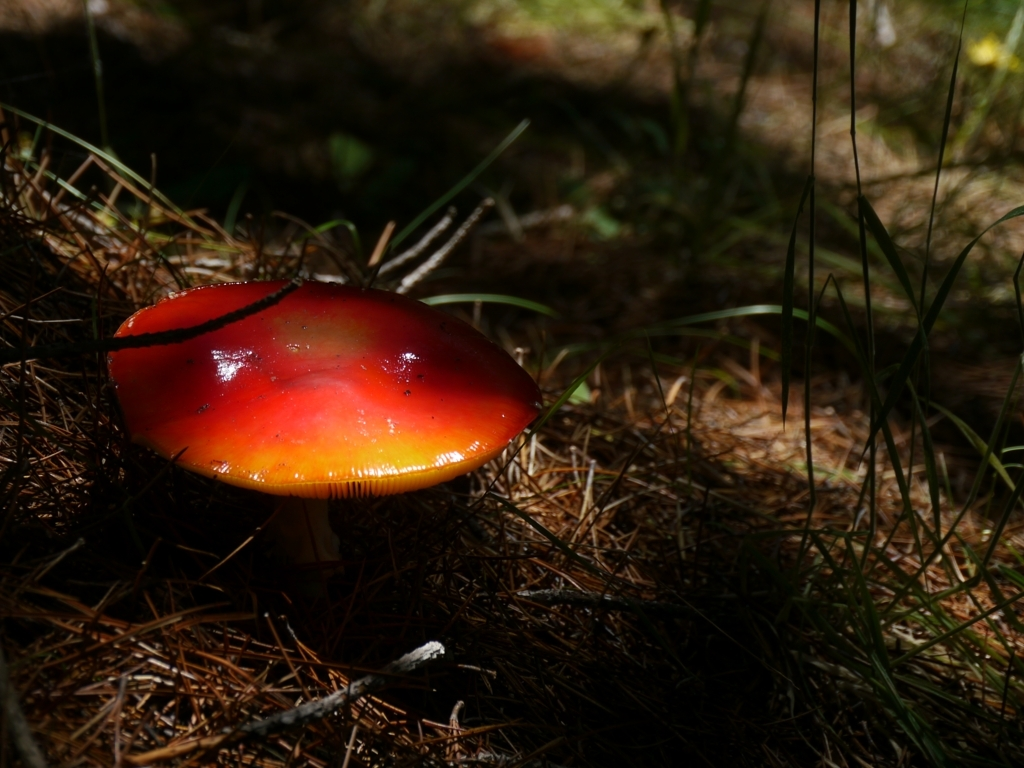What species might this mushroom be, and is it edible or poisonous? The mushroom in the image appears to resemble a member of the genus Amanita, which is known for having both edible and highly toxic species. Without more specific information, it's not safe to make a determination on edibility. Mistaking a poisonous Amanita for an edible species could have severe consequences. If you're interested in foraging mushrooms, it's crucial to consult a local expert or a reliable field guide. 